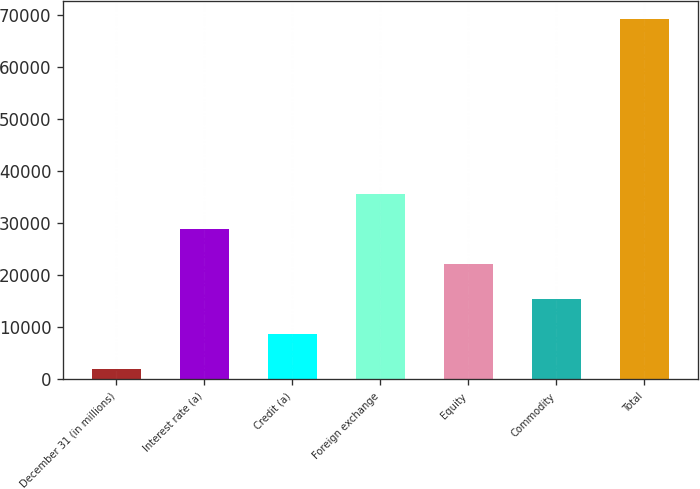Convert chart to OTSL. <chart><loc_0><loc_0><loc_500><loc_500><bar_chart><fcel>December 31 (in millions)<fcel>Interest rate (a)<fcel>Credit (a)<fcel>Foreign exchange<fcel>Equity<fcel>Commodity<fcel>Total<nl><fcel>2010<fcel>28893.6<fcel>8730.9<fcel>35614.5<fcel>22172.7<fcel>15451.8<fcel>69219<nl></chart> 